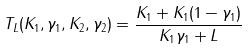<formula> <loc_0><loc_0><loc_500><loc_500>T _ { L } ( K _ { 1 } , \gamma _ { 1 } , K _ { 2 } , \gamma _ { 2 } ) = \frac { K _ { 1 } + K _ { 1 } ( 1 - \gamma _ { 1 } ) } { K _ { 1 } \gamma _ { 1 } + L }</formula> 